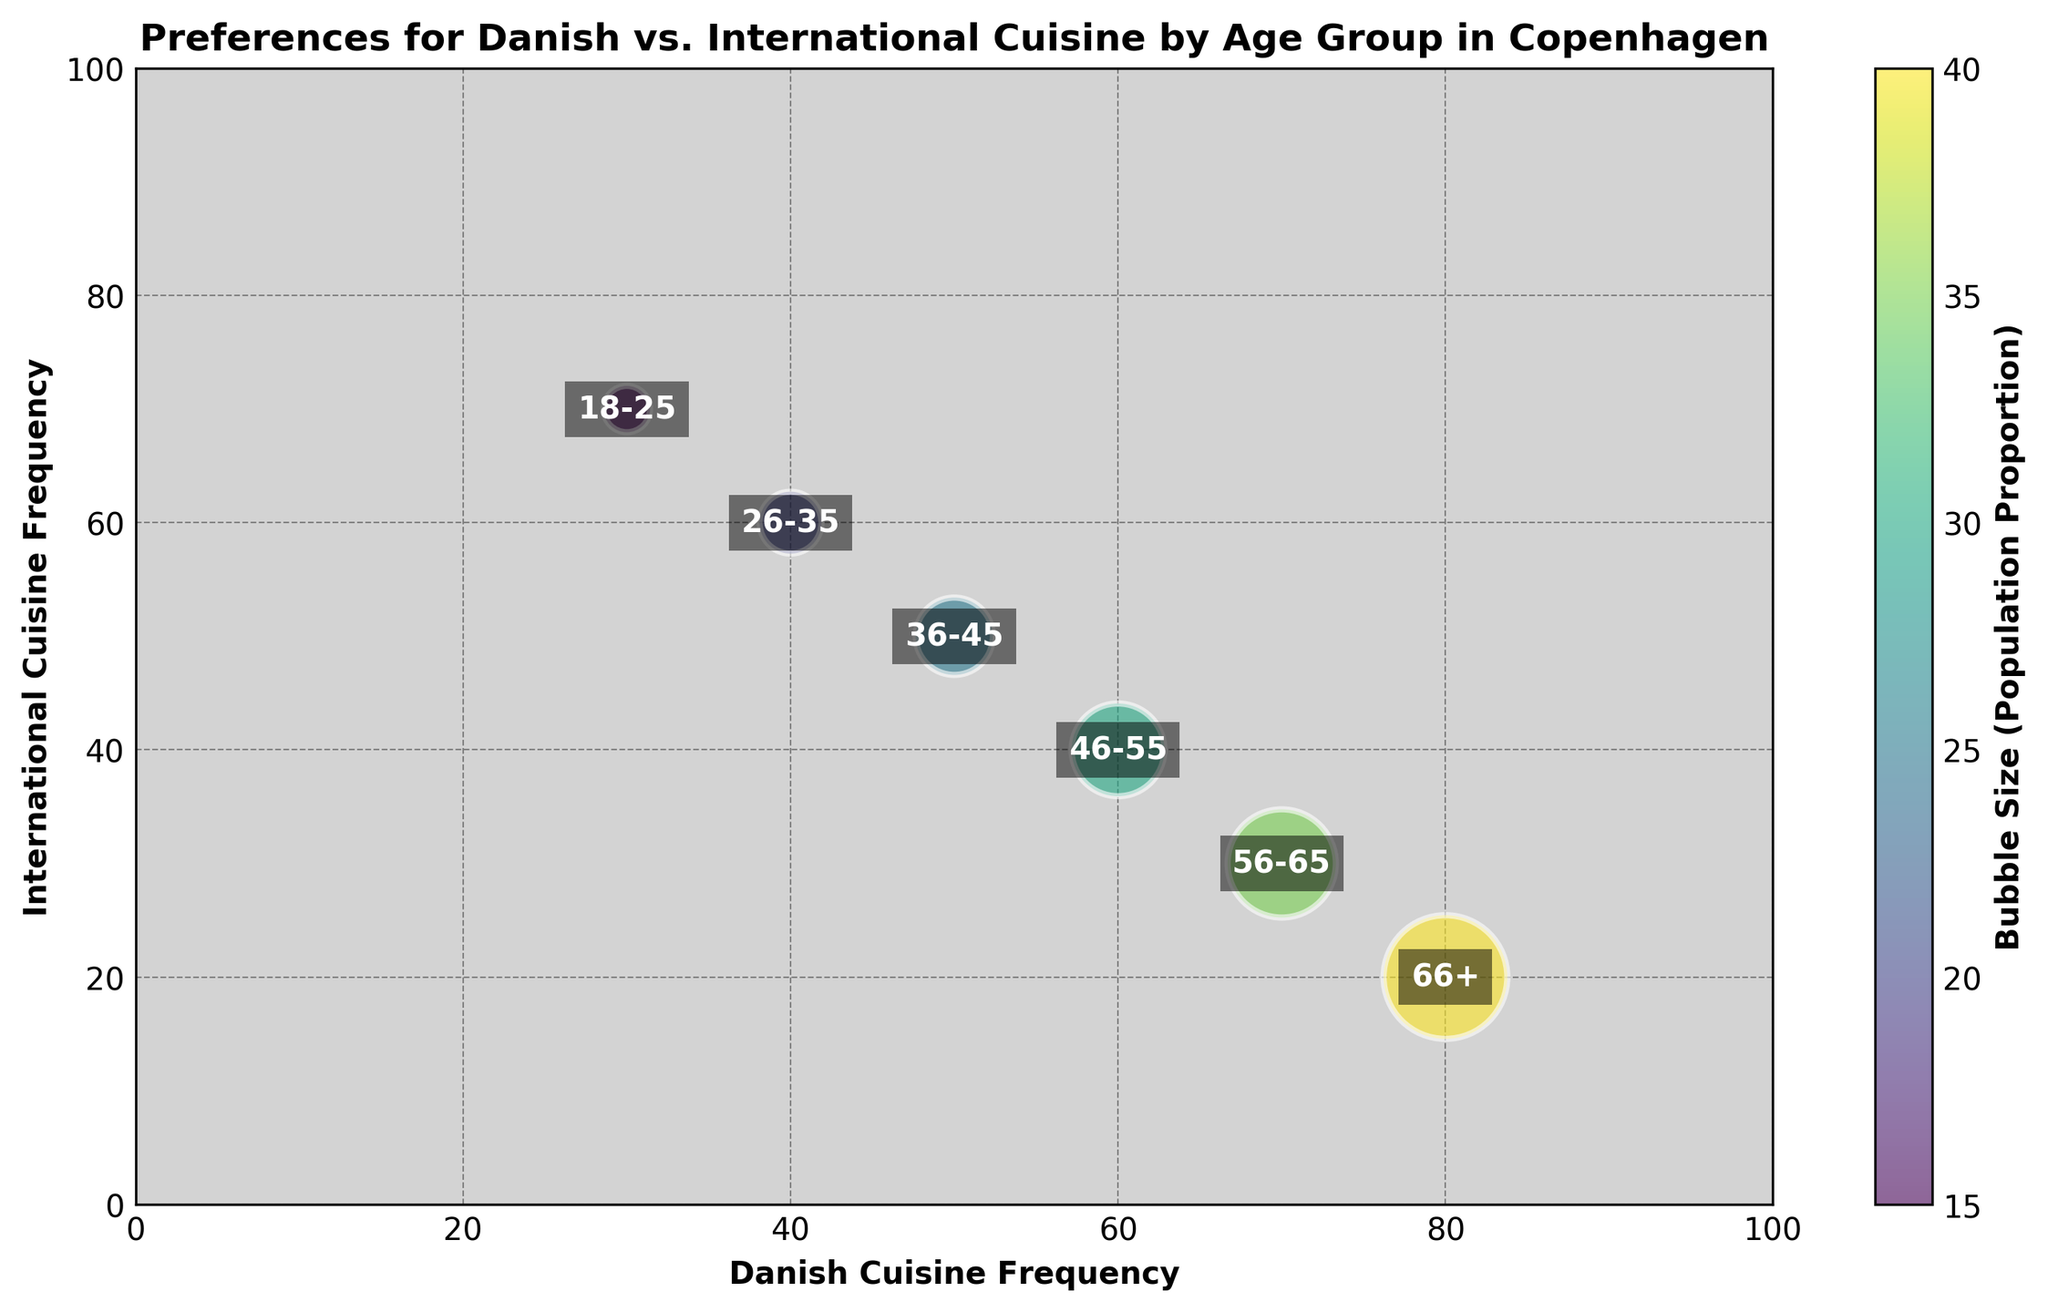Which age group has the highest preference for Danish cuisine? The age group with the highest preference for Danish cuisine will have the largest value on the Danish Cuisine Frequency axis. Here, the '66+' age group has the highest Danish Cuisine Frequency at 80.
Answer: 66+ Which age group prefers international cuisine the most? To find the age group with the highest preference for international cuisine, look for the largest value on the International Cuisine Frequency axis. The '18-25' age group has the highest preference for international cuisine at 70.
Answer: 18-25 Which two age groups have an equal preference for Danish and International cuisines? To find age groups with equal preferences, look for points where the Danish and International Cuisine Frequency values are the same. The '36-45' age group shows a balance with both frequencies at 50.
Answer: 36-45 What is the average Danish Cuisine Frequency for the '18-25' and '26-35' age groups combined? Sum the Danish Cuisine Frequencies for '18-25' and '26-35' age groups and then divide by 2: (30 + 40) / 2 = 70 / 2 = 35
Answer: 35 Which age group has the smallest bubble size, and what does it signify? Locate the smallest bubble visually, which represents the '18-25' age group with a size of 15. This signifies the population proportion among the age groups.
Answer: 18-25 Compare the Danish Cuisine Frequency of '46-55' age group to the International Cuisine Frequency of '26-35' age group. Which is higher? Check the values for Danish Cuisine Frequency of '46-55' (60) and International Cuisine Frequency of '26-35' (60). Both values are equal.
Answer: Both are equal What is the difference in International Cuisine Frequency between the '56-65' and '66+' age groups? Subtract the International Cuisine Frequency of '66+' age group from that of '56-65': 30 - 20 = 10
Answer: 10 Estimate the average Bubble Size across all age groups. Sum all Bubble Sizes and divide by the number of groups: (15 + 20 + 25 + 30 + 35 + 40) / 6 = 165 / 6 ≈ 27.5
Answer: 27.5 Which age group shows a more balanced preference for both cuisines? Look for age groups where the Danish and International Cuisine Frequency values are closer to each other. The '36-45' age group has the most balanced preferences, both at 50.
Answer: 36-45 Which age group shows a higher preference for Danish cuisine compared to International cuisine? Identify age groups where Danish Cuisine Frequency is higher than International Cuisine Frequency: '46-55', '56-65', and '66+'
Answer: '46-55', '56-65', '66+' 